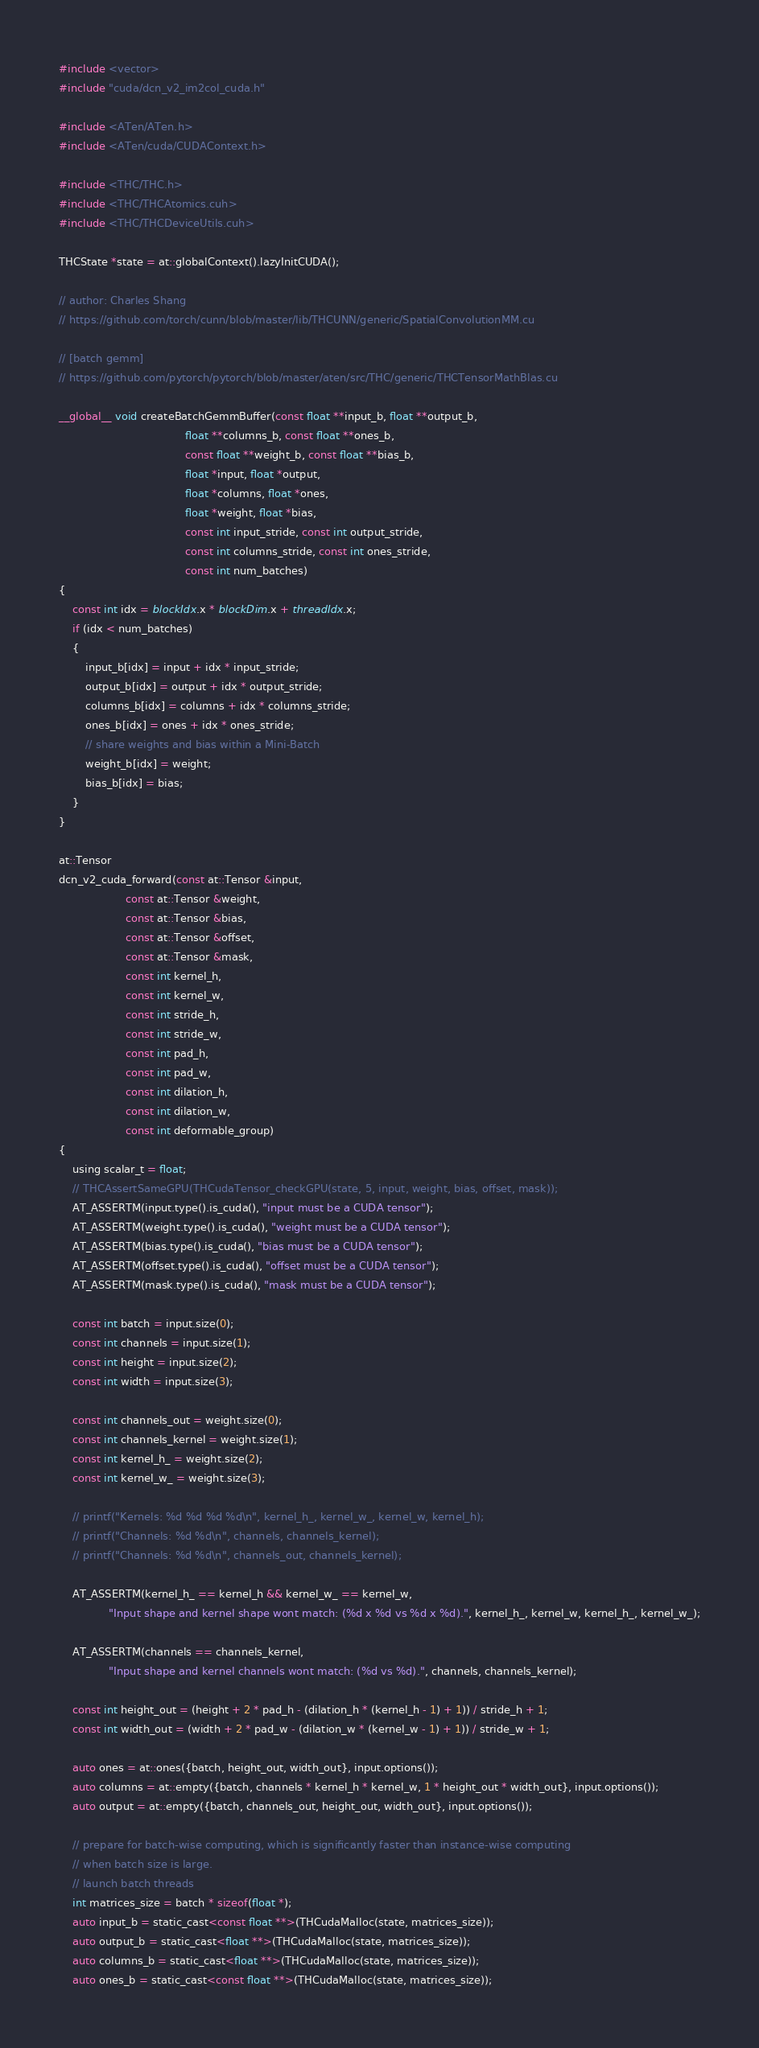<code> <loc_0><loc_0><loc_500><loc_500><_Cuda_>#include <vector>
#include "cuda/dcn_v2_im2col_cuda.h"

#include <ATen/ATen.h>
#include <ATen/cuda/CUDAContext.h>

#include <THC/THC.h>
#include <THC/THCAtomics.cuh>
#include <THC/THCDeviceUtils.cuh>

THCState *state = at::globalContext().lazyInitCUDA();

// author: Charles Shang
// https://github.com/torch/cunn/blob/master/lib/THCUNN/generic/SpatialConvolutionMM.cu

// [batch gemm]
// https://github.com/pytorch/pytorch/blob/master/aten/src/THC/generic/THCTensorMathBlas.cu

__global__ void createBatchGemmBuffer(const float **input_b, float **output_b,
                                      float **columns_b, const float **ones_b,
                                      const float **weight_b, const float **bias_b,
                                      float *input, float *output,
                                      float *columns, float *ones,
                                      float *weight, float *bias,
                                      const int input_stride, const int output_stride,
                                      const int columns_stride, const int ones_stride,
                                      const int num_batches)
{
    const int idx = blockIdx.x * blockDim.x + threadIdx.x;
    if (idx < num_batches)
    {
        input_b[idx] = input + idx * input_stride;
        output_b[idx] = output + idx * output_stride;
        columns_b[idx] = columns + idx * columns_stride;
        ones_b[idx] = ones + idx * ones_stride;
        // share weights and bias within a Mini-Batch
        weight_b[idx] = weight;
        bias_b[idx] = bias;
    }
}

at::Tensor
dcn_v2_cuda_forward(const at::Tensor &input,
                    const at::Tensor &weight,
                    const at::Tensor &bias,
                    const at::Tensor &offset,
                    const at::Tensor &mask,
                    const int kernel_h,
                    const int kernel_w,
                    const int stride_h,
                    const int stride_w,
                    const int pad_h,
                    const int pad_w,
                    const int dilation_h,
                    const int dilation_w,
                    const int deformable_group)
{
    using scalar_t = float;
    // THCAssertSameGPU(THCudaTensor_checkGPU(state, 5, input, weight, bias, offset, mask));
    AT_ASSERTM(input.type().is_cuda(), "input must be a CUDA tensor");
    AT_ASSERTM(weight.type().is_cuda(), "weight must be a CUDA tensor");
    AT_ASSERTM(bias.type().is_cuda(), "bias must be a CUDA tensor");
    AT_ASSERTM(offset.type().is_cuda(), "offset must be a CUDA tensor");
    AT_ASSERTM(mask.type().is_cuda(), "mask must be a CUDA tensor");

    const int batch = input.size(0);
    const int channels = input.size(1);
    const int height = input.size(2);
    const int width = input.size(3);

    const int channels_out = weight.size(0);
    const int channels_kernel = weight.size(1);
    const int kernel_h_ = weight.size(2);
    const int kernel_w_ = weight.size(3);

    // printf("Kernels: %d %d %d %d\n", kernel_h_, kernel_w_, kernel_w, kernel_h);
    // printf("Channels: %d %d\n", channels, channels_kernel);
    // printf("Channels: %d %d\n", channels_out, channels_kernel);

    AT_ASSERTM(kernel_h_ == kernel_h && kernel_w_ == kernel_w,
               "Input shape and kernel shape wont match: (%d x %d vs %d x %d).", kernel_h_, kernel_w, kernel_h_, kernel_w_);

    AT_ASSERTM(channels == channels_kernel,
               "Input shape and kernel channels wont match: (%d vs %d).", channels, channels_kernel);

    const int height_out = (height + 2 * pad_h - (dilation_h * (kernel_h - 1) + 1)) / stride_h + 1;
    const int width_out = (width + 2 * pad_w - (dilation_w * (kernel_w - 1) + 1)) / stride_w + 1;

    auto ones = at::ones({batch, height_out, width_out}, input.options());
    auto columns = at::empty({batch, channels * kernel_h * kernel_w, 1 * height_out * width_out}, input.options());
    auto output = at::empty({batch, channels_out, height_out, width_out}, input.options());

    // prepare for batch-wise computing, which is significantly faster than instance-wise computing
    // when batch size is large.
    // launch batch threads
    int matrices_size = batch * sizeof(float *);
    auto input_b = static_cast<const float **>(THCudaMalloc(state, matrices_size));
    auto output_b = static_cast<float **>(THCudaMalloc(state, matrices_size));
    auto columns_b = static_cast<float **>(THCudaMalloc(state, matrices_size));
    auto ones_b = static_cast<const float **>(THCudaMalloc(state, matrices_size));</code> 